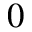Convert formula to latex. <formula><loc_0><loc_0><loc_500><loc_500>_ { 0 }</formula> 